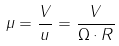Convert formula to latex. <formula><loc_0><loc_0><loc_500><loc_500>\mu = \frac { V } { u } = \frac { V } { \Omega \cdot R }</formula> 